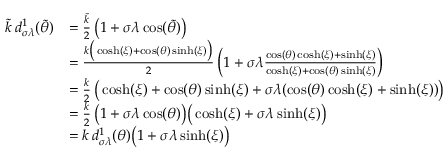<formula> <loc_0><loc_0><loc_500><loc_500>\begin{array} { r l } { \tilde { k } \, d _ { \sigma \lambda } ^ { 1 } ( \tilde { \theta } ) } & { = \frac { \tilde { k } } { 2 } \, \left ( 1 + \sigma \lambda \cos ( \tilde { \theta } ) \right ) } \\ & { = \frac { k \left ( \cosh ( \xi ) + \cos ( \theta ) \sinh ( \xi ) \right ) } { 2 } \, \left ( 1 + \sigma \lambda \frac { \cos ( \theta ) \cosh ( \xi ) + \sinh ( \xi ) } { \cosh ( \xi ) + \cos ( \theta ) \sinh ( \xi ) } \right ) } \\ & { = \frac { k } { 2 } \, \left ( \cosh ( \xi ) + \cos ( \theta ) \sinh ( \xi ) + \sigma \lambda ( \cos ( \theta ) \cosh ( \xi ) + \sinh ( \xi ) ) \right ) } \\ & { = \frac { k } { 2 } \, \left ( 1 + \sigma \lambda \cos ( \theta ) \right ) \left ( \cosh ( \xi ) + \sigma \lambda \sinh ( \xi ) \right ) } \\ & { = k \, d _ { \sigma \lambda } ^ { 1 } ( \theta ) \left ( 1 + \sigma \lambda \sinh ( \xi ) \right ) } \end{array}</formula> 